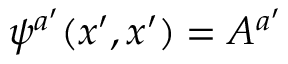<formula> <loc_0><loc_0><loc_500><loc_500>\psi ^ { a ^ { \prime } } ( x ^ { \prime } , x ^ { \prime } ) = A ^ { a ^ { \prime } }</formula> 